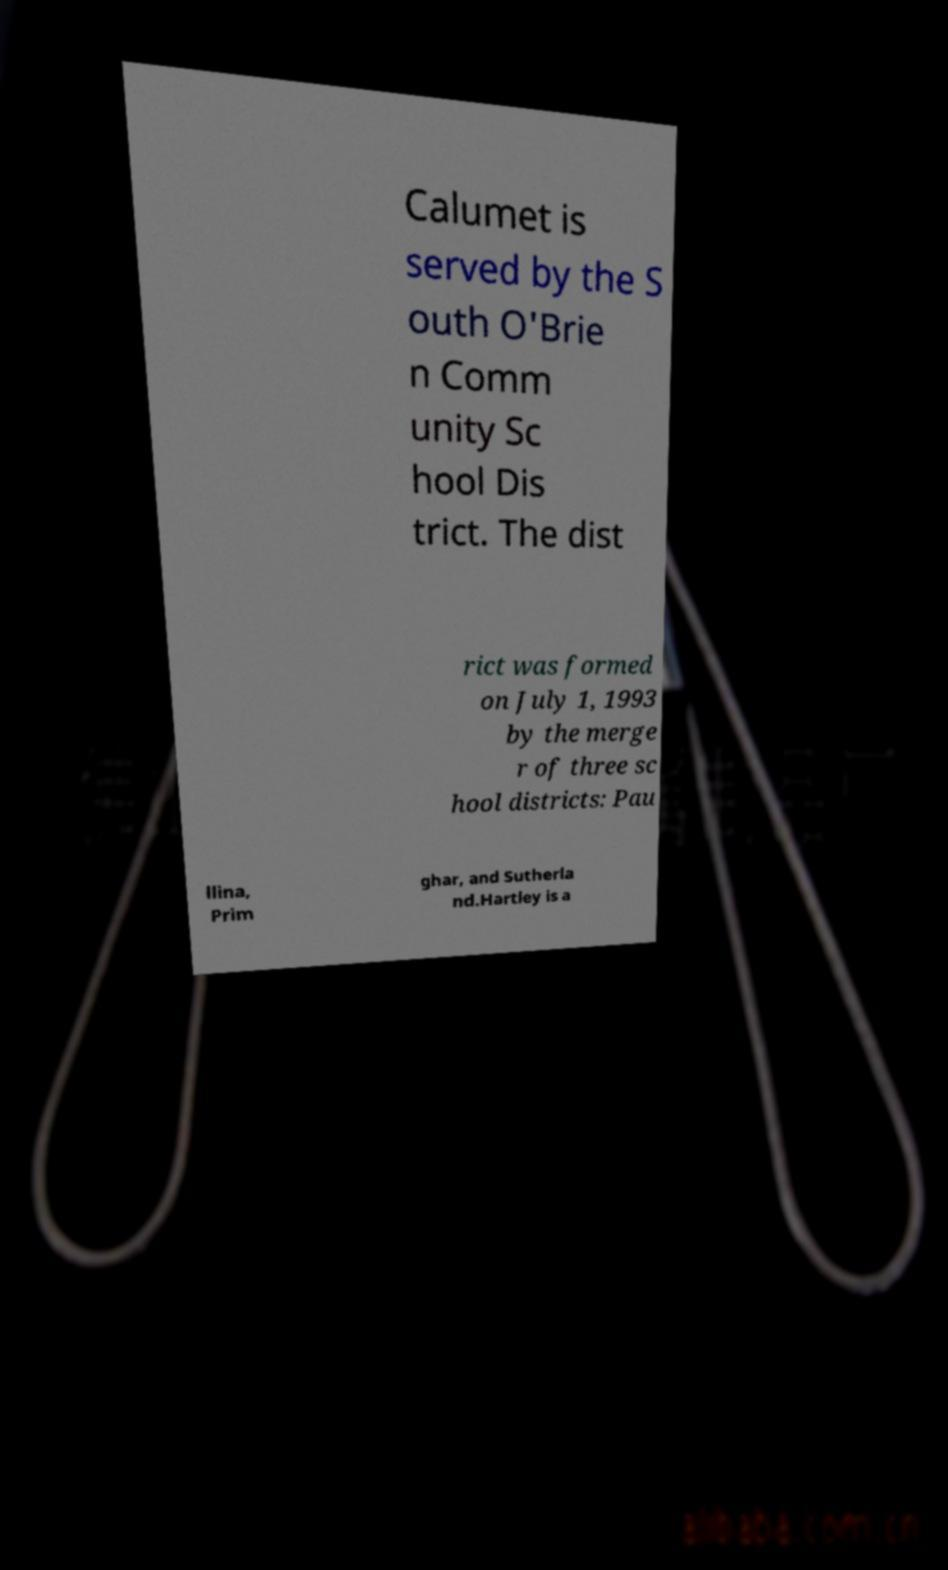Please read and relay the text visible in this image. What does it say? Calumet is served by the S outh O'Brie n Comm unity Sc hool Dis trict. The dist rict was formed on July 1, 1993 by the merge r of three sc hool districts: Pau llina, Prim ghar, and Sutherla nd.Hartley is a 